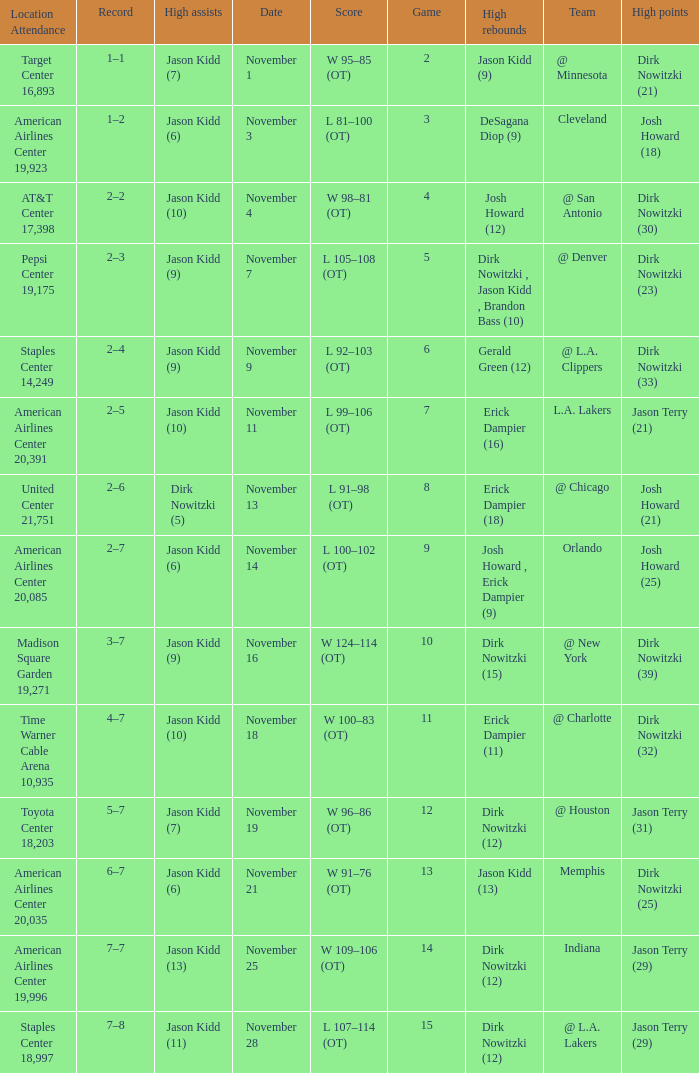What was the record on November 7? 1.0. 